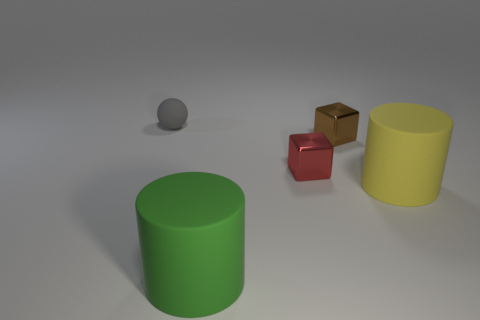Add 4 small matte balls. How many objects exist? 9 Subtract all spheres. How many objects are left? 4 Subtract all tiny green objects. Subtract all gray rubber balls. How many objects are left? 4 Add 1 red objects. How many red objects are left? 2 Add 1 metallic cubes. How many metallic cubes exist? 3 Subtract 1 green cylinders. How many objects are left? 4 